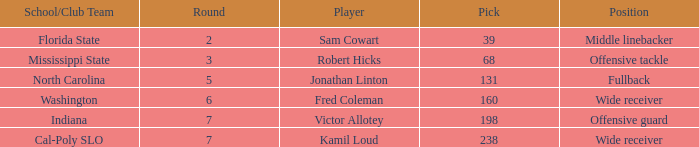Which Round has a School/Club Team of indiana, and a Pick smaller than 198? None. 